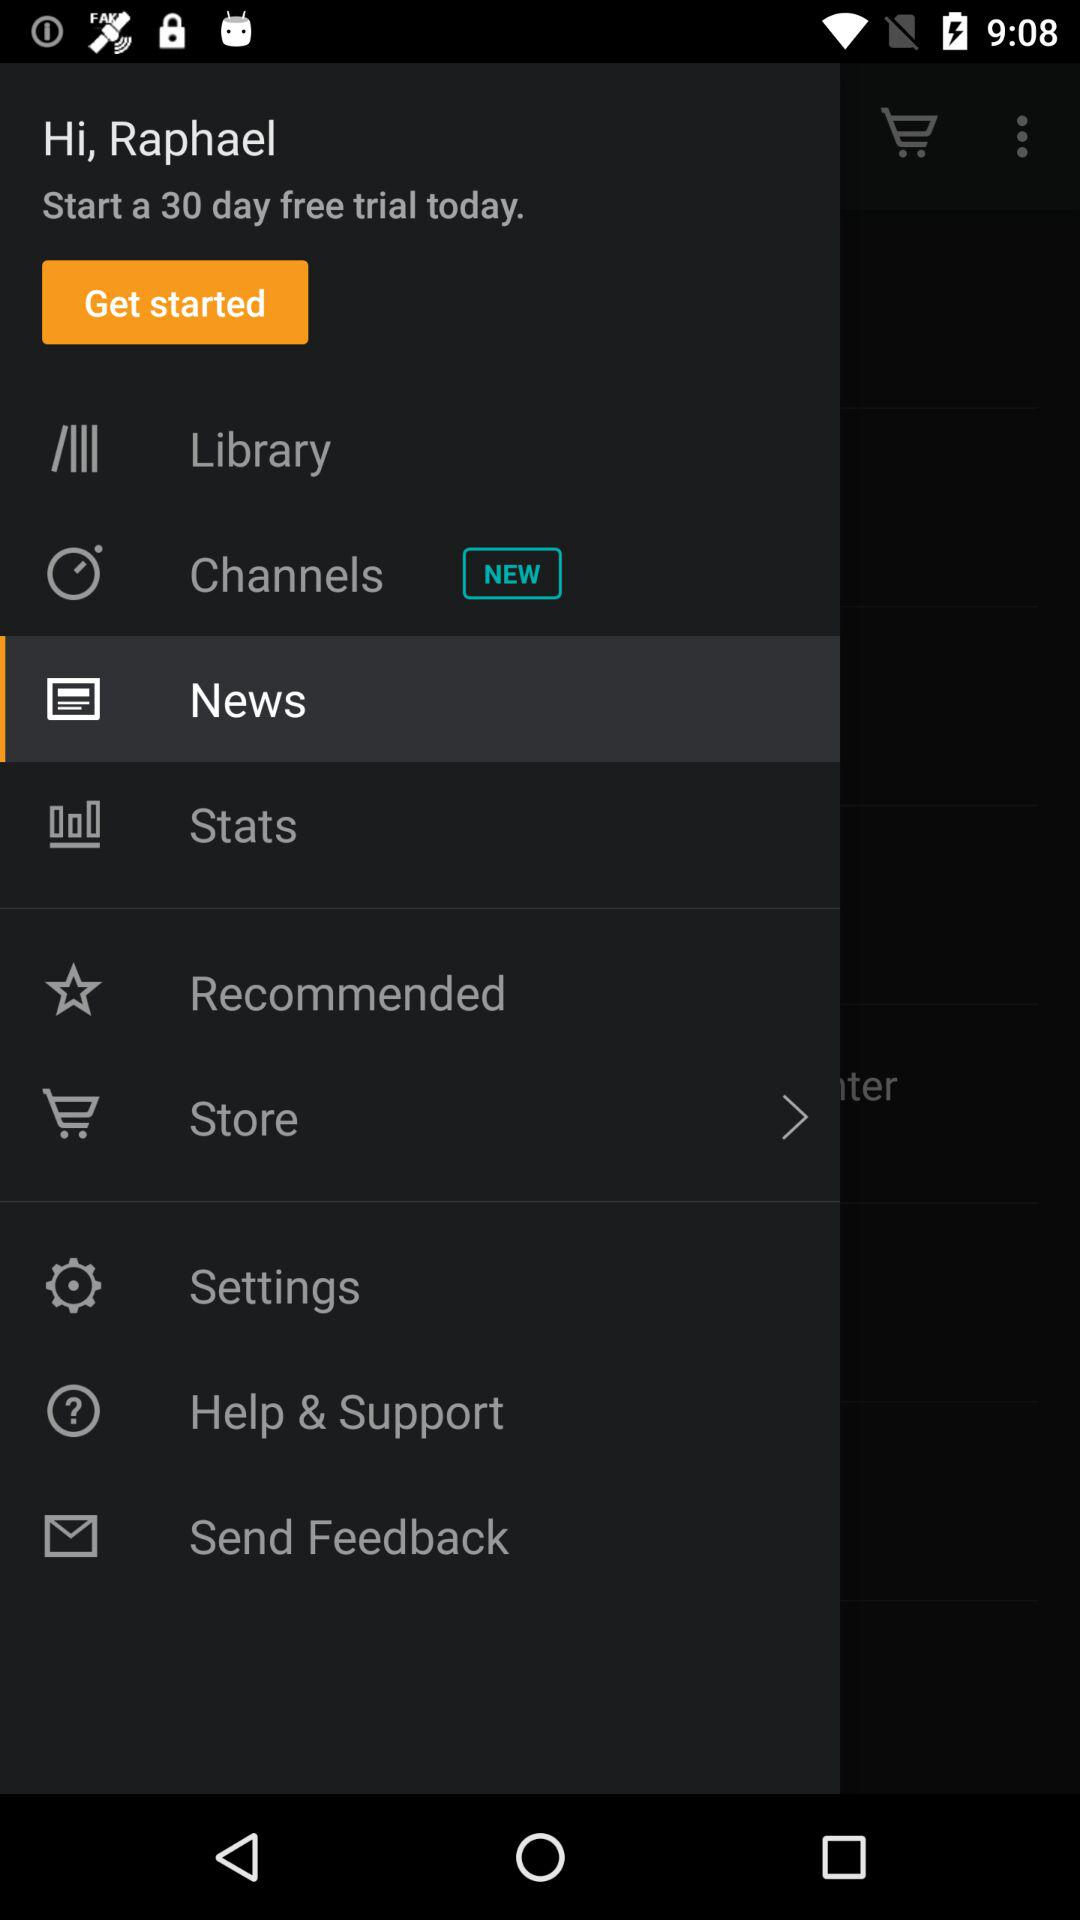When can the free trial be started? The free trail can be started today. 